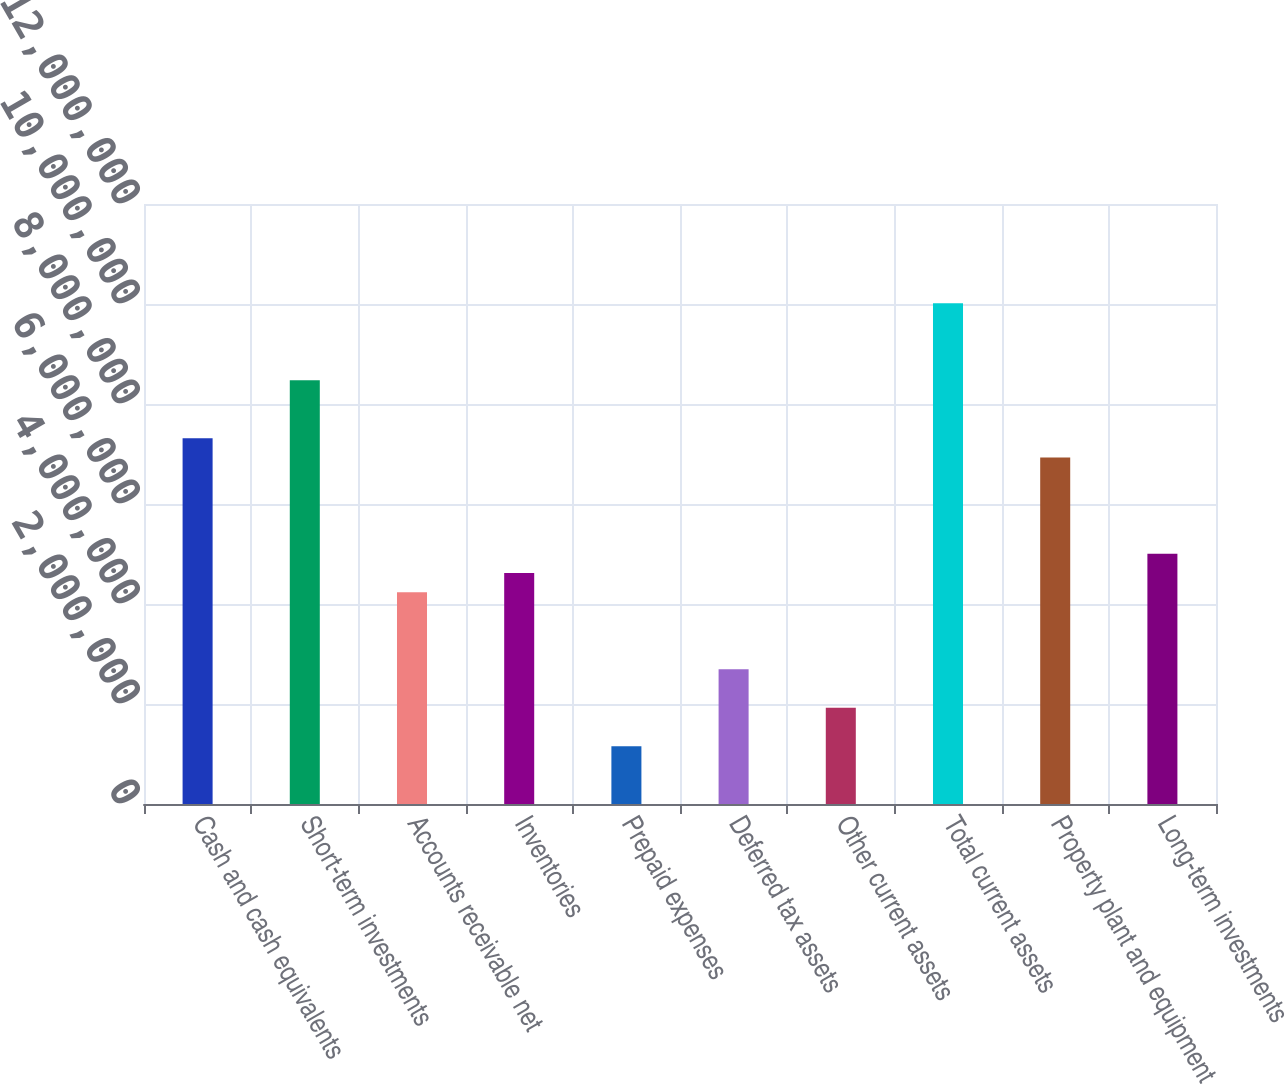Convert chart to OTSL. <chart><loc_0><loc_0><loc_500><loc_500><bar_chart><fcel>Cash and cash equivalents<fcel>Short-term investments<fcel>Accounts receivable net<fcel>Inventories<fcel>Prepaid expenses<fcel>Deferred tax assets<fcel>Other current assets<fcel>Total current assets<fcel>Property plant and equipment<fcel>Long-term investments<nl><fcel>7.31749e+06<fcel>8.47286e+06<fcel>4.23653e+06<fcel>4.62165e+06<fcel>1.15556e+06<fcel>2.69604e+06<fcel>1.9258e+06<fcel>1.00133e+07<fcel>6.93237e+06<fcel>5.00677e+06<nl></chart> 